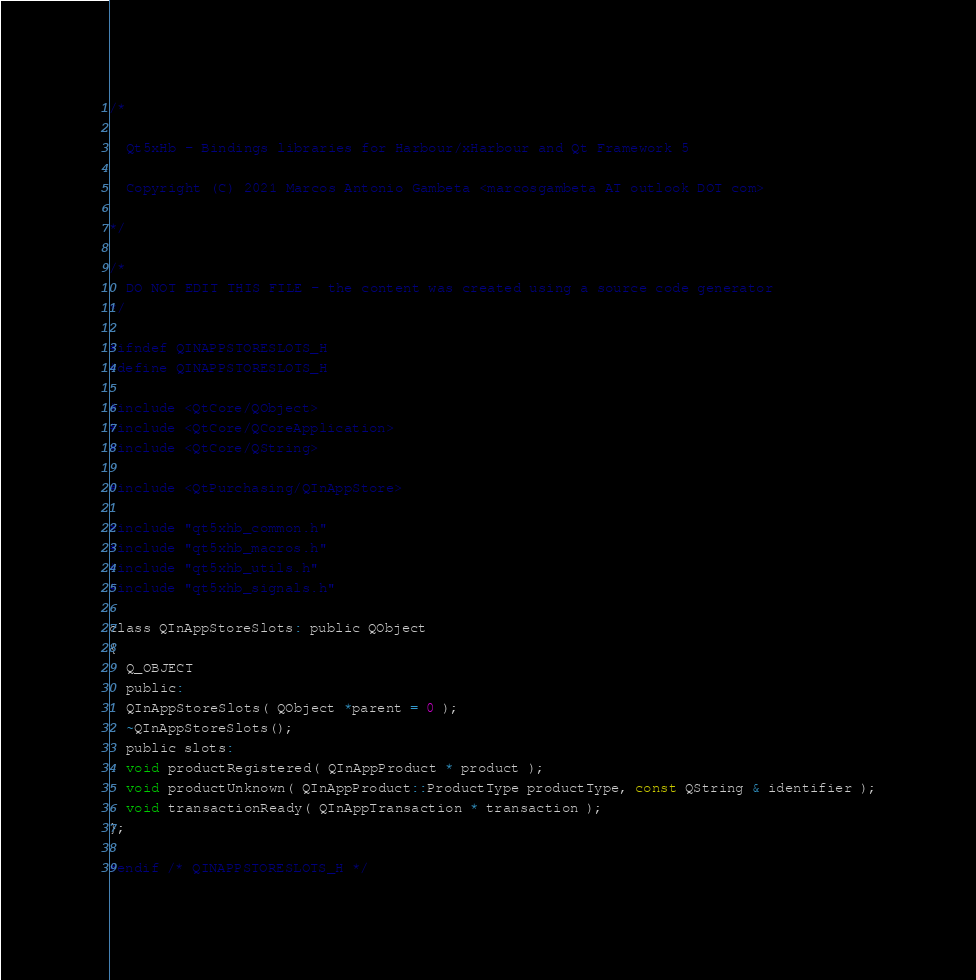Convert code to text. <code><loc_0><loc_0><loc_500><loc_500><_C_>/*

  Qt5xHb - Bindings libraries for Harbour/xHarbour and Qt Framework 5

  Copyright (C) 2021 Marcos Antonio Gambeta <marcosgambeta AT outlook DOT com>

*/

/*
  DO NOT EDIT THIS FILE - the content was created using a source code generator
*/

#ifndef QINAPPSTORESLOTS_H
#define QINAPPSTORESLOTS_H

#include <QtCore/QObject>
#include <QtCore/QCoreApplication>
#include <QtCore/QString>

#include <QtPurchasing/QInAppStore>

#include "qt5xhb_common.h"
#include "qt5xhb_macros.h"
#include "qt5xhb_utils.h"
#include "qt5xhb_signals.h"

class QInAppStoreSlots: public QObject
{
  Q_OBJECT
  public:
  QInAppStoreSlots( QObject *parent = 0 );
  ~QInAppStoreSlots();
  public slots:
  void productRegistered( QInAppProduct * product );
  void productUnknown( QInAppProduct::ProductType productType, const QString & identifier );
  void transactionReady( QInAppTransaction * transaction );
};

#endif /* QINAPPSTORESLOTS_H */
</code> 